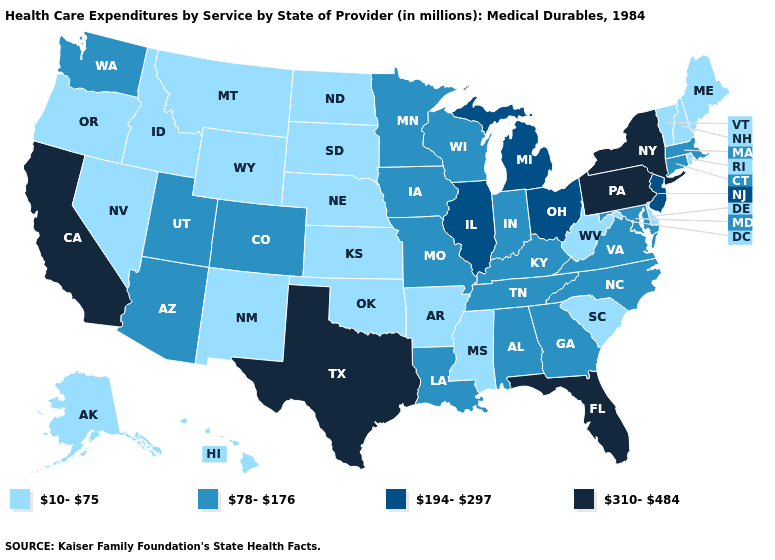Name the states that have a value in the range 310-484?
Write a very short answer. California, Florida, New York, Pennsylvania, Texas. Does North Dakota have a lower value than Georgia?
Answer briefly. Yes. Does Michigan have the lowest value in the MidWest?
Answer briefly. No. Which states have the lowest value in the Northeast?
Give a very brief answer. Maine, New Hampshire, Rhode Island, Vermont. Name the states that have a value in the range 78-176?
Concise answer only. Alabama, Arizona, Colorado, Connecticut, Georgia, Indiana, Iowa, Kentucky, Louisiana, Maryland, Massachusetts, Minnesota, Missouri, North Carolina, Tennessee, Utah, Virginia, Washington, Wisconsin. Does Oklahoma have the lowest value in the USA?
Write a very short answer. Yes. Which states have the lowest value in the USA?
Be succinct. Alaska, Arkansas, Delaware, Hawaii, Idaho, Kansas, Maine, Mississippi, Montana, Nebraska, Nevada, New Hampshire, New Mexico, North Dakota, Oklahoma, Oregon, Rhode Island, South Carolina, South Dakota, Vermont, West Virginia, Wyoming. Name the states that have a value in the range 310-484?
Quick response, please. California, Florida, New York, Pennsylvania, Texas. What is the value of Rhode Island?
Give a very brief answer. 10-75. Does West Virginia have the lowest value in the USA?
Quick response, please. Yes. Does Delaware have the same value as Texas?
Be succinct. No. What is the value of West Virginia?
Write a very short answer. 10-75. Does Hawaii have the lowest value in the West?
Quick response, please. Yes. Name the states that have a value in the range 310-484?
Be succinct. California, Florida, New York, Pennsylvania, Texas. What is the value of North Dakota?
Short answer required. 10-75. 